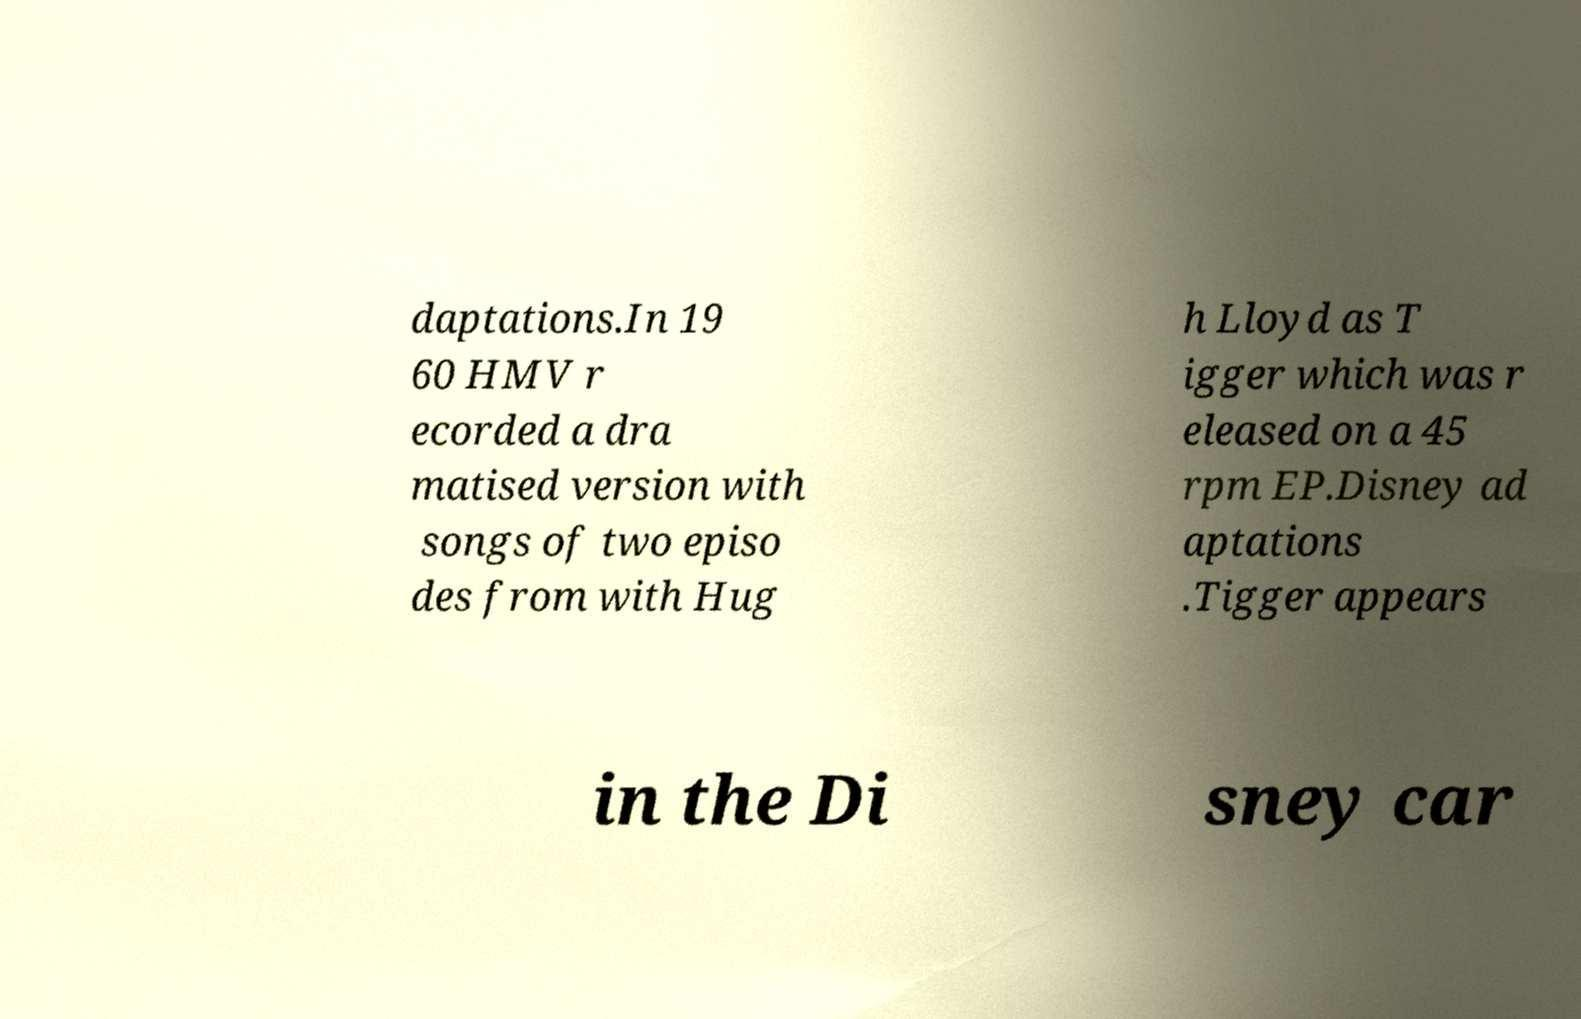Can you accurately transcribe the text from the provided image for me? daptations.In 19 60 HMV r ecorded a dra matised version with songs of two episo des from with Hug h Lloyd as T igger which was r eleased on a 45 rpm EP.Disney ad aptations .Tigger appears in the Di sney car 